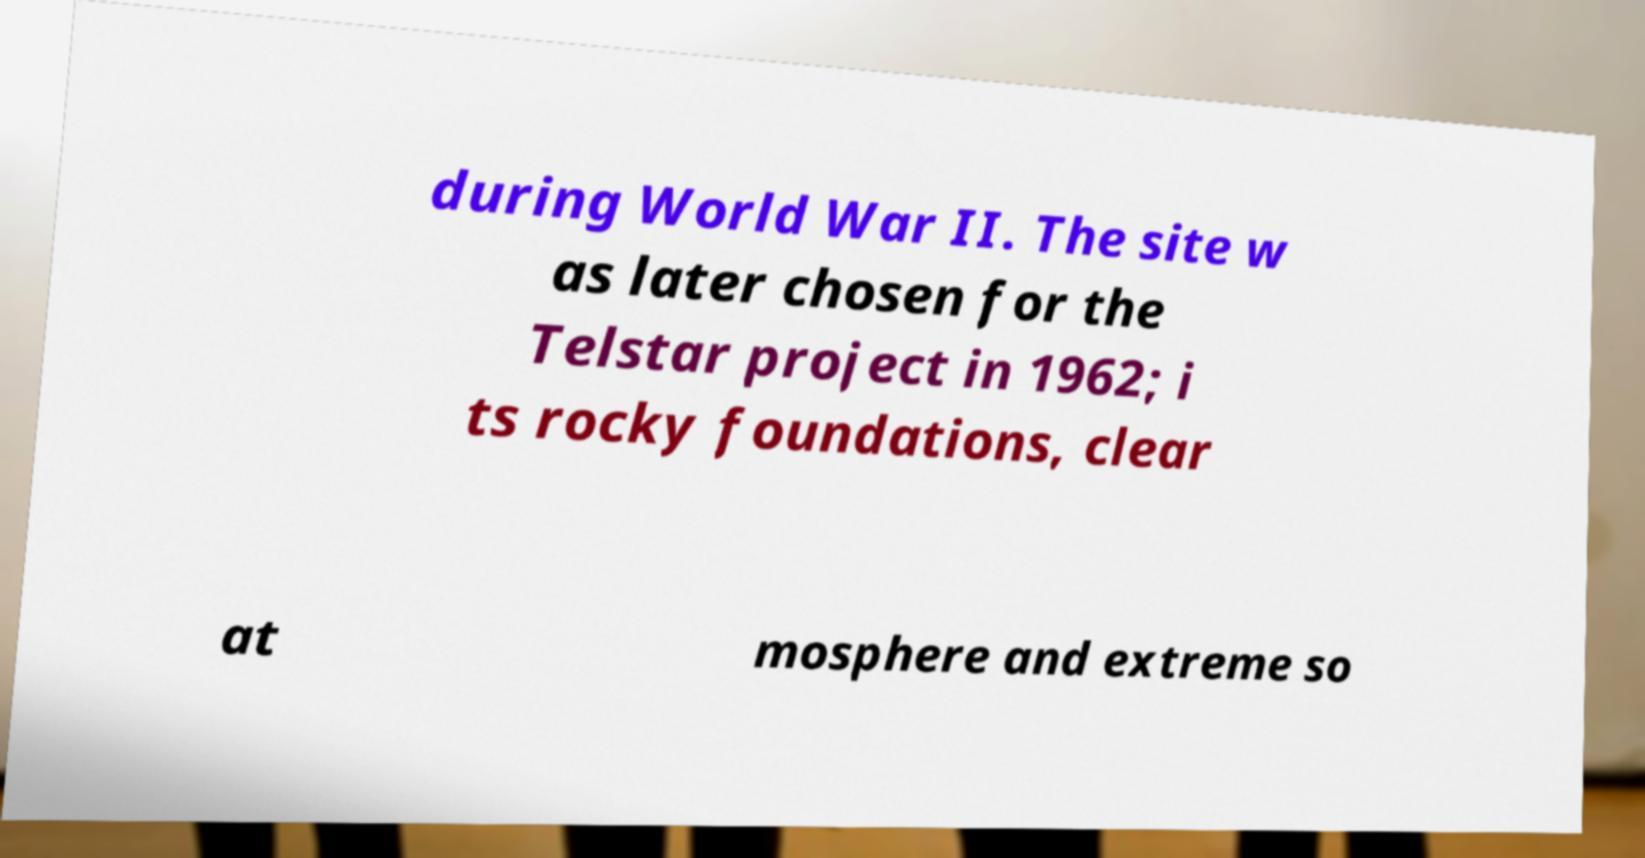For documentation purposes, I need the text within this image transcribed. Could you provide that? during World War II. The site w as later chosen for the Telstar project in 1962; i ts rocky foundations, clear at mosphere and extreme so 